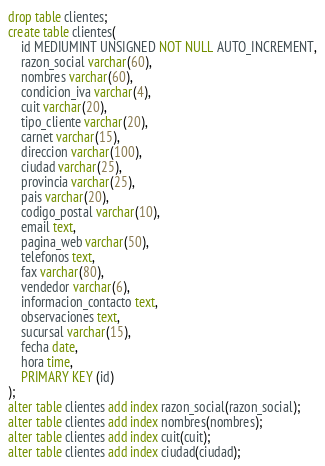<code> <loc_0><loc_0><loc_500><loc_500><_SQL_>drop table clientes;
create table clientes(
    id MEDIUMINT UNSIGNED NOT NULL AUTO_INCREMENT,
    razon_social varchar(60),
    nombres varchar(60),
    condicion_iva varchar(4),
    cuit varchar(20),
    tipo_cliente varchar(20),
    carnet varchar(15),
    direccion varchar(100),
    ciudad varchar(25),
    provincia varchar(25),
    pais varchar(20),
    codigo_postal varchar(10),
    email text,
    pagina_web varchar(50),
    telefonos text,
    fax varchar(80),
    vendedor varchar(6),
    informacion_contacto text,
    observaciones text,
    sucursal varchar(15),
    fecha date,
    hora time,
    PRIMARY KEY (id)
);
alter table clientes add index razon_social(razon_social);
alter table clientes add index nombres(nombres);
alter table clientes add index cuit(cuit);
alter table clientes add index ciudad(ciudad);

</code> 